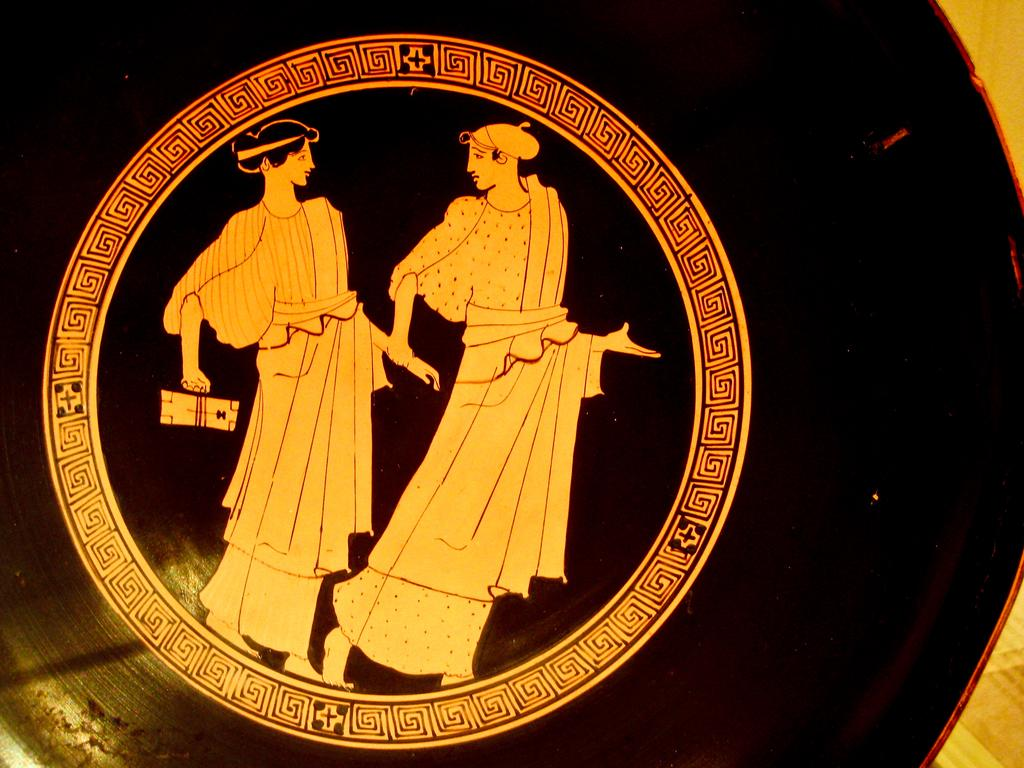How many people are in the image? There are two people in the image, a man and a woman. What is the man doing with the woman in the image? The man is holding the woman's hand in the image. What is the owner of the hand doing in the image? There is no mention of an owner in the image, and the image only shows a man holding the woman's hand. Can you tell me how angry the man looks in the image? The image does not provide any information about the man's emotions, so it cannot be determined if he looks angry or not. 